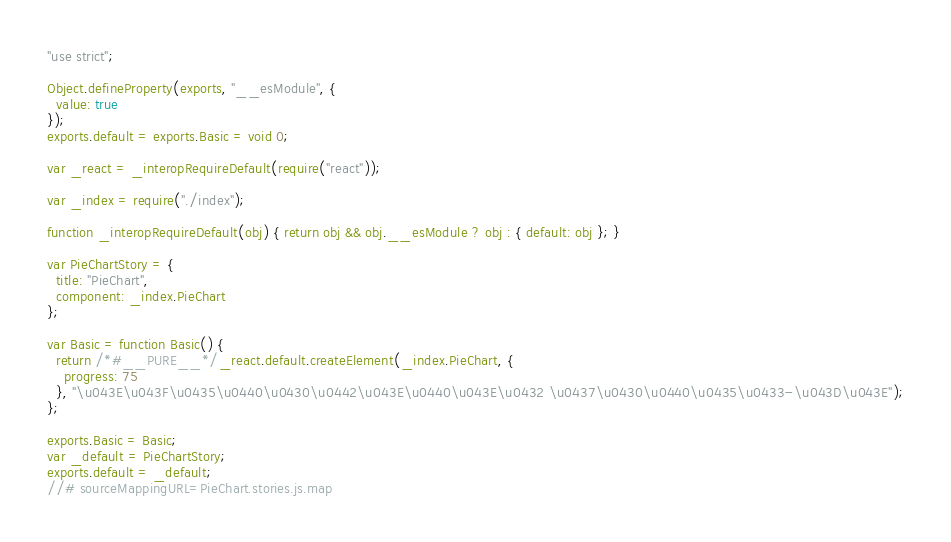Convert code to text. <code><loc_0><loc_0><loc_500><loc_500><_JavaScript_>"use strict";

Object.defineProperty(exports, "__esModule", {
  value: true
});
exports.default = exports.Basic = void 0;

var _react = _interopRequireDefault(require("react"));

var _index = require("./index");

function _interopRequireDefault(obj) { return obj && obj.__esModule ? obj : { default: obj }; }

var PieChartStory = {
  title: "PieChart",
  component: _index.PieChart
};

var Basic = function Basic() {
  return /*#__PURE__*/_react.default.createElement(_index.PieChart, {
    progress: 75
  }, "\u043E\u043F\u0435\u0440\u0430\u0442\u043E\u0440\u043E\u0432 \u0437\u0430\u0440\u0435\u0433-\u043D\u043E");
};

exports.Basic = Basic;
var _default = PieChartStory;
exports.default = _default;
//# sourceMappingURL=PieChart.stories.js.map</code> 